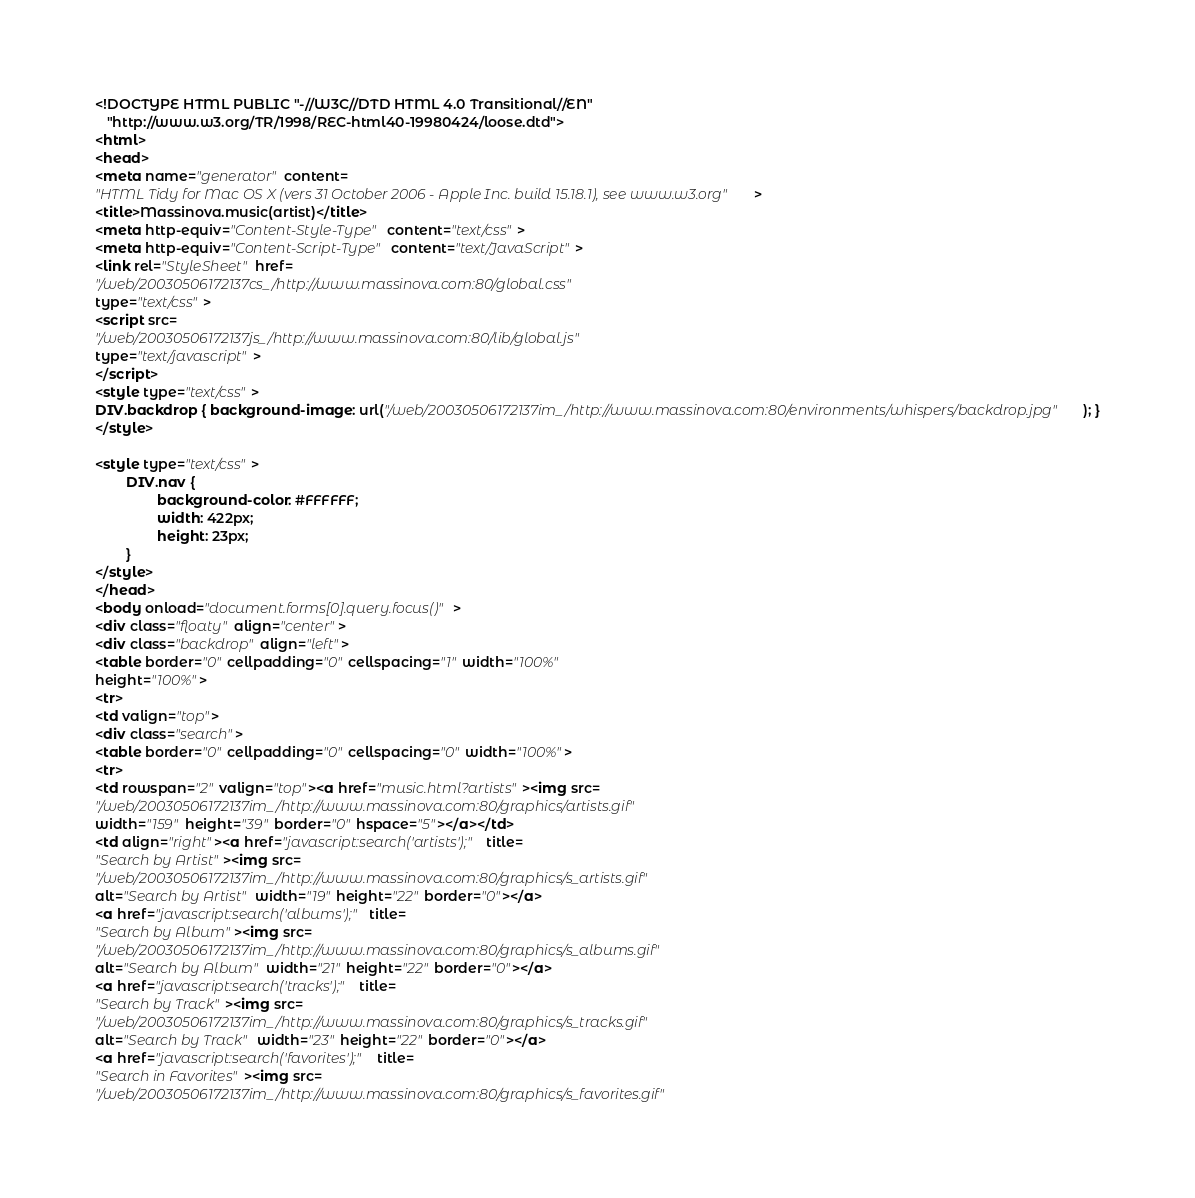<code> <loc_0><loc_0><loc_500><loc_500><_HTML_><!DOCTYPE HTML PUBLIC "-//W3C//DTD HTML 4.0 Transitional//EN"
   "http://www.w3.org/TR/1998/REC-html40-19980424/loose.dtd">
<html>
<head>
<meta name="generator" content=
"HTML Tidy for Mac OS X (vers 31 October 2006 - Apple Inc. build 15.18.1), see www.w3.org">
<title>Massinova.music(artist)</title>
<meta http-equiv="Content-Style-Type" content="text/css">
<meta http-equiv="Content-Script-Type" content="text/JavaScript">
<link rel="StyleSheet" href=
"/web/20030506172137cs_/http://www.massinova.com:80/global.css"
type="text/css">
<script src=
"/web/20030506172137js_/http://www.massinova.com:80/lib/global.js"
type="text/javascript">
</script>
<style type="text/css">
DIV.backdrop { background-image: url("/web/20030506172137im_/http://www.massinova.com:80/environments/whispers/backdrop.jpg"); }
</style>

<style type="text/css">
        DIV.nav {
                background-color: #FFFFFF; 
                width: 422px;
                height: 23px;
        }
</style>
</head>
<body onload="document.forms[0].query.focus()">
<div class="floaty" align="center">
<div class="backdrop" align="left">
<table border="0" cellpadding="0" cellspacing="1" width="100%"
height="100%">
<tr>
<td valign="top">
<div class="search">
<table border="0" cellpadding="0" cellspacing="0" width="100%">
<tr>
<td rowspan="2" valign="top"><a href="music.html?artists"><img src=
"/web/20030506172137im_/http://www.massinova.com:80/graphics/artists.gif"
width="159" height="39" border="0" hspace="5"></a></td>
<td align="right"><a href="javascript:search('artists');" title=
"Search by Artist"><img src=
"/web/20030506172137im_/http://www.massinova.com:80/graphics/s_artists.gif"
alt="Search by Artist" width="19" height="22" border="0"></a>
<a href="javascript:search('albums');" title=
"Search by Album"><img src=
"/web/20030506172137im_/http://www.massinova.com:80/graphics/s_albums.gif"
alt="Search by Album" width="21" height="22" border="0"></a>
<a href="javascript:search('tracks');" title=
"Search by Track"><img src=
"/web/20030506172137im_/http://www.massinova.com:80/graphics/s_tracks.gif"
alt="Search by Track" width="23" height="22" border="0"></a>
<a href="javascript:search('favorites');" title=
"Search in Favorites"><img src=
"/web/20030506172137im_/http://www.massinova.com:80/graphics/s_favorites.gif"</code> 